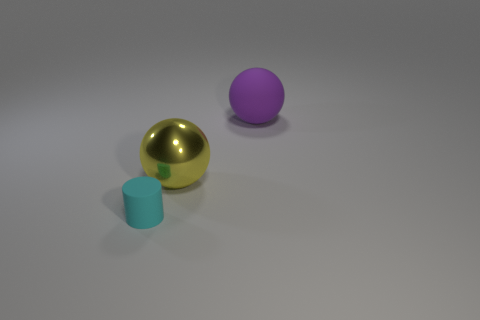How would you interpret the arrangement of these objects? The arrangement of objects appears deliberately spaced, with a golden sphere, a cyan cylinder, and a large purple ball creating a sense of balanced composition. This could symbolize concepts like harmony, order, and diversity, as each object's unique color and shape stand out while also contributing to the overall aesthetics of the setup.  What might the different colors of the objects signify? Colors can have various interpretations depending on context and culture. In this image, the golden sphere may suggest value or wealth, cyan might evoke feelings of calm and tranquility, and purple could represent creativity or luxury. The colors create a visually engaging contrast that can also be playful, encouraging viewers to find their own meaning.  Do the objects appear to have any function or are they purely decorative? Without additional context, it's difficult to assign a specific function to these objects. They appear more as geometric shapes typically used for aesthetic purposes in visual arts, design studies, or 3D modeling practices. Their simplistic design suggests that they might be part of a larger conceptual project or are meant for decorative purposes within this particular setting. 